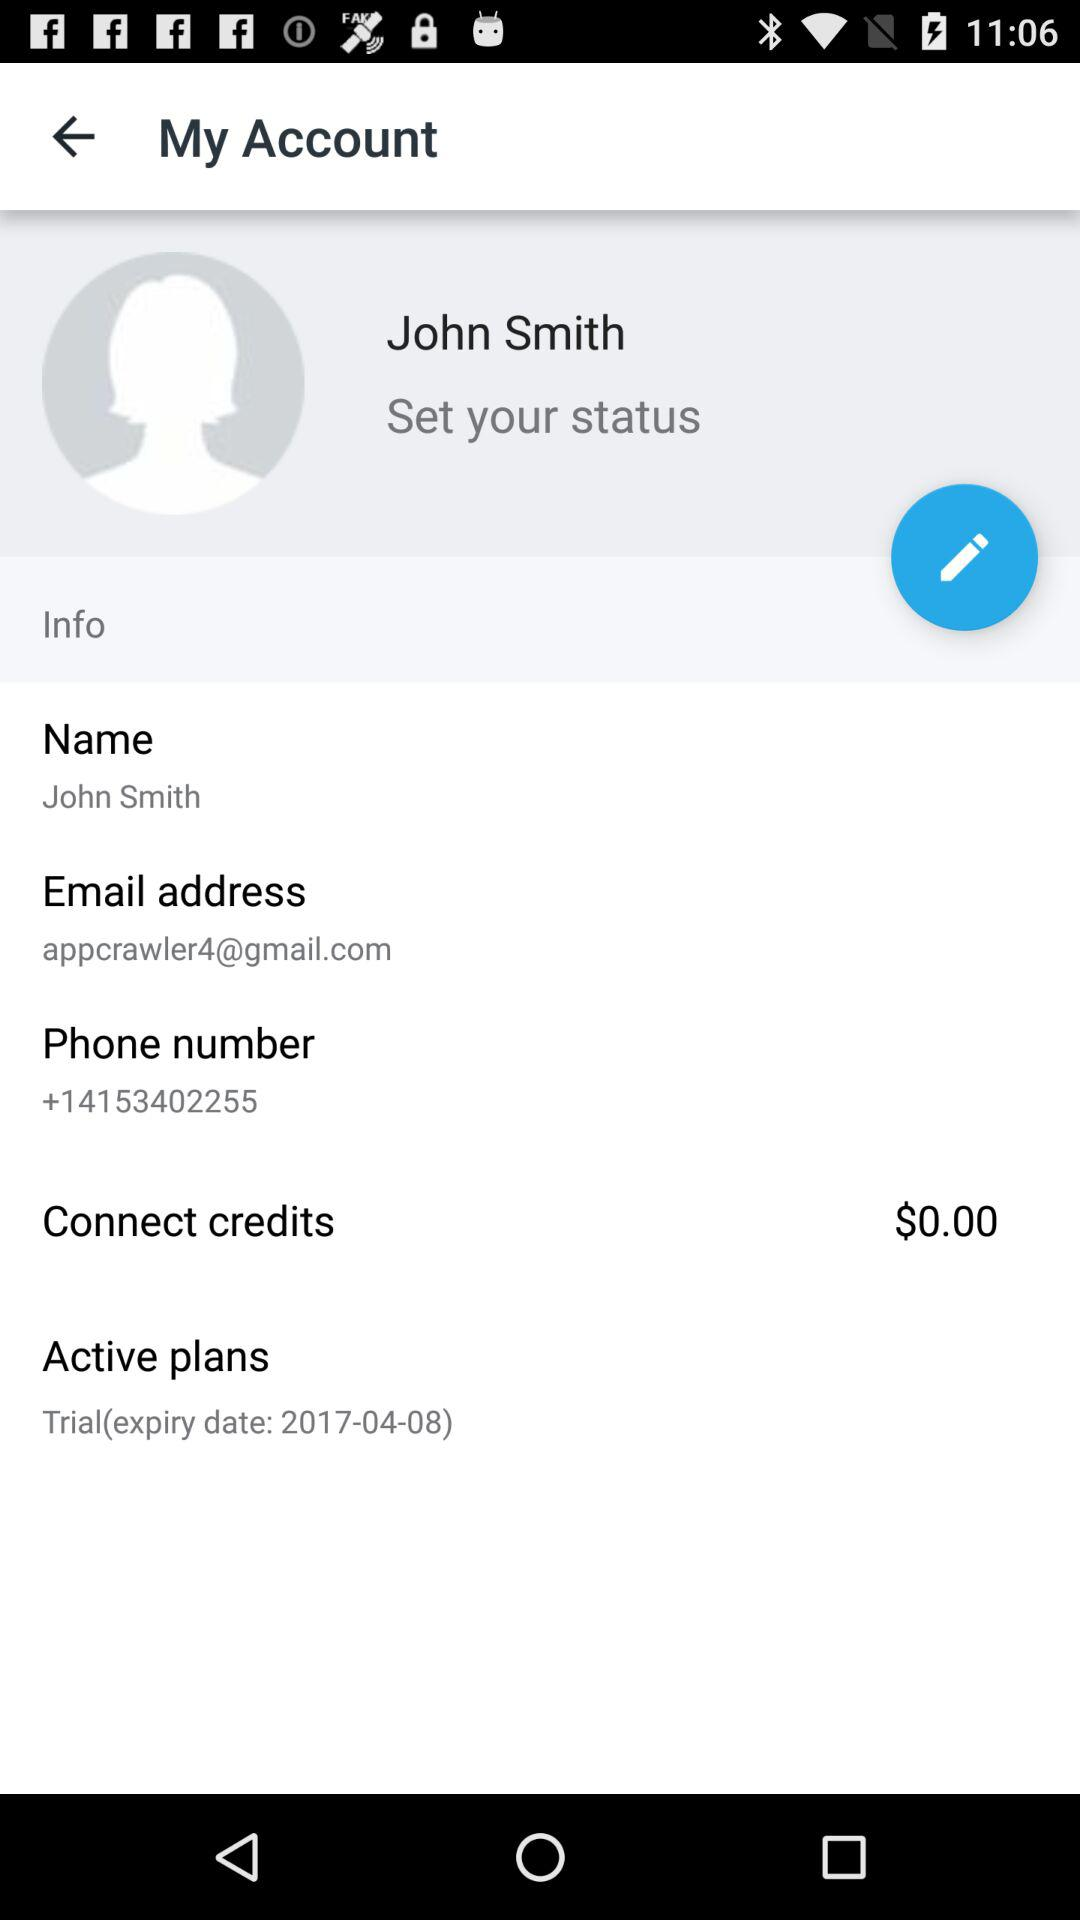What is the phone number? The phone number is +14153402255. 